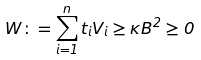Convert formula to latex. <formula><loc_0><loc_0><loc_500><loc_500>W \colon = \sum _ { i = 1 } ^ { n } t _ { i } V _ { i } \geq \kappa B ^ { 2 } \geq 0</formula> 